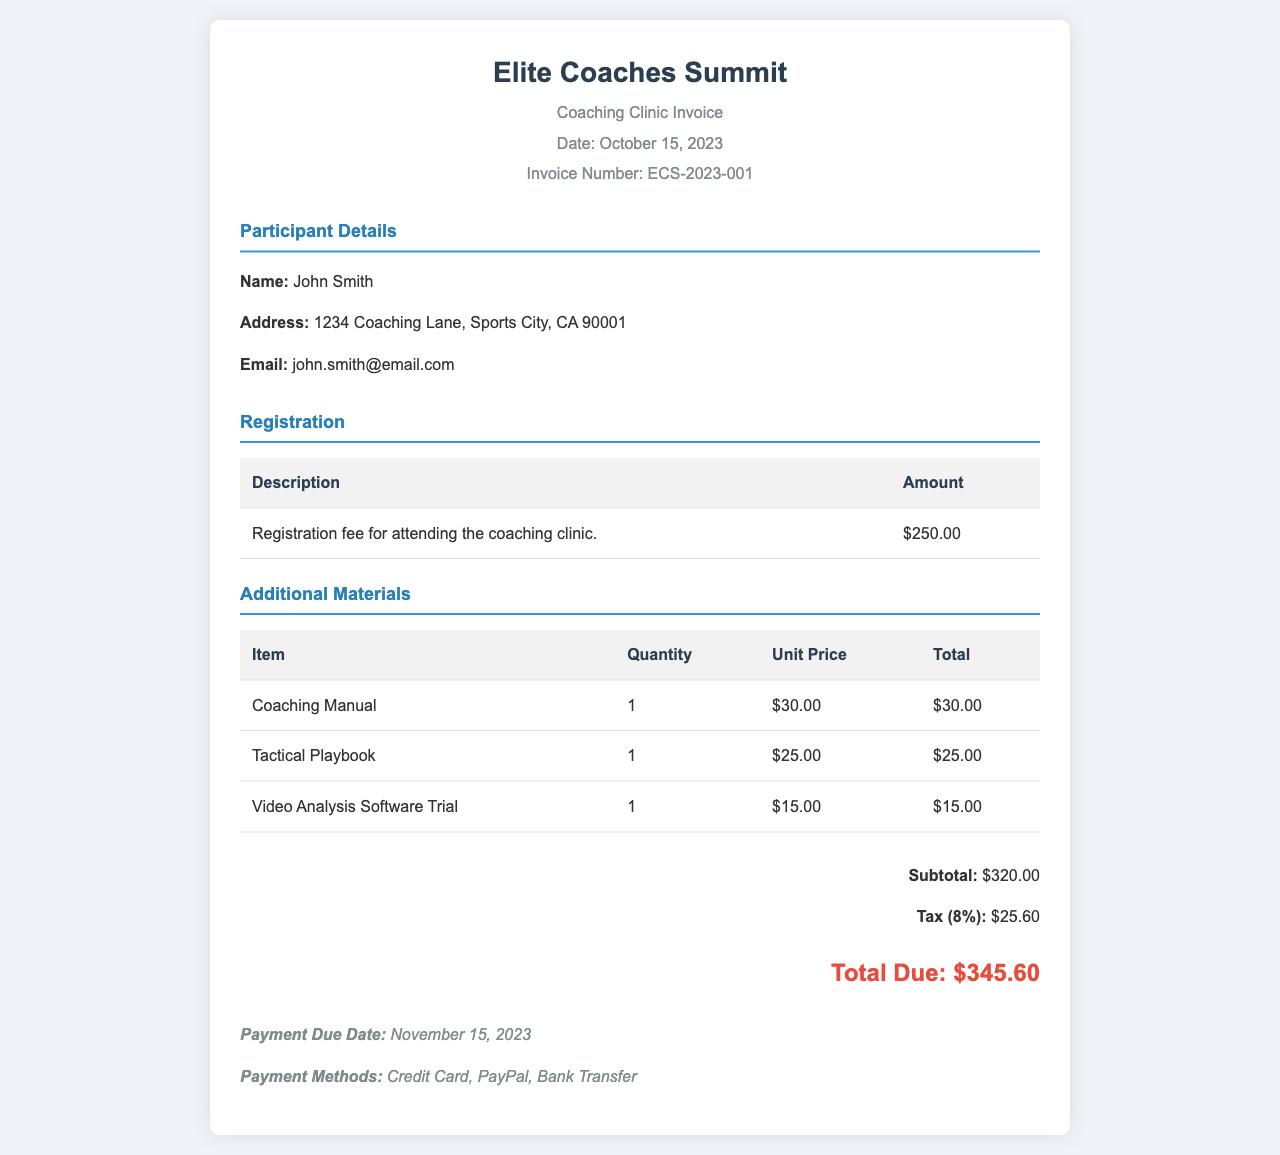What is the name of the clinic? The name of the clinic is stated in the header of the document as "Elite Coaches Summit."
Answer: Elite Coaches Summit What is the registration fee? The registration fee can be found in the Registration section, which lists it as $250.00.
Answer: $250.00 What is the total due amount? The total due amount is indicated at the bottom of the document and sums up the subtotal and tax, which is $345.60.
Answer: $345.60 Who is the participant? The participant's name is provided in the Participant Details section as "John Smith."
Answer: John Smith What is the tax rate applied? The tax is explicitly stated to be 8% in the total summary section.
Answer: 8% How many additional materials are listed? Three additional materials are described in the Additional Materials section of the document.
Answer: Three What is the due date for payment? The payment due date is mentioned in the payment terms section as November 15, 2023.
Answer: November 15, 2023 Which method of payment is accepted? The document lists accepted payment methods as Credit Card, PayPal, and Bank Transfer.
Answer: Credit Card, PayPal, Bank Transfer What is the total cost of the Coaching Manual? The Coaching Manual's cost is specified as $30.00 in the Additional Materials table.
Answer: $30.00 